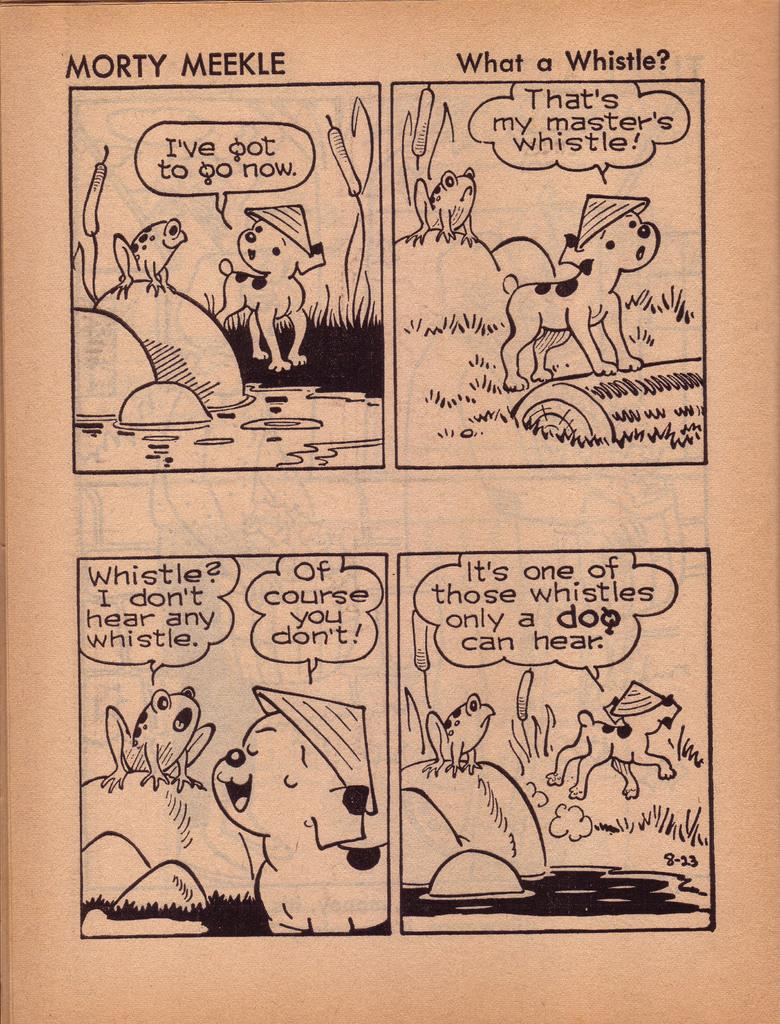<image>
Share a concise interpretation of the image provided. Comic strip showing a dog and a frog by Morty Meekle. 